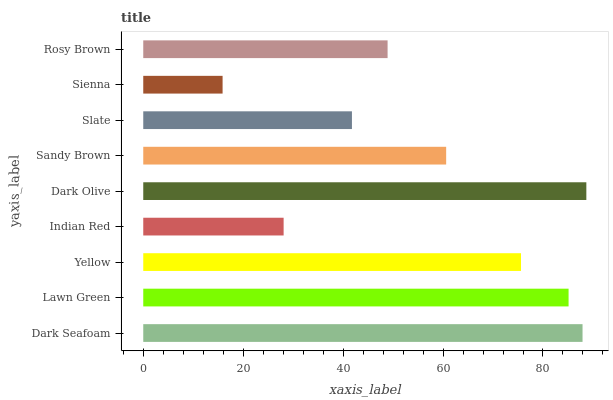Is Sienna the minimum?
Answer yes or no. Yes. Is Dark Olive the maximum?
Answer yes or no. Yes. Is Lawn Green the minimum?
Answer yes or no. No. Is Lawn Green the maximum?
Answer yes or no. No. Is Dark Seafoam greater than Lawn Green?
Answer yes or no. Yes. Is Lawn Green less than Dark Seafoam?
Answer yes or no. Yes. Is Lawn Green greater than Dark Seafoam?
Answer yes or no. No. Is Dark Seafoam less than Lawn Green?
Answer yes or no. No. Is Sandy Brown the high median?
Answer yes or no. Yes. Is Sandy Brown the low median?
Answer yes or no. Yes. Is Indian Red the high median?
Answer yes or no. No. Is Dark Olive the low median?
Answer yes or no. No. 